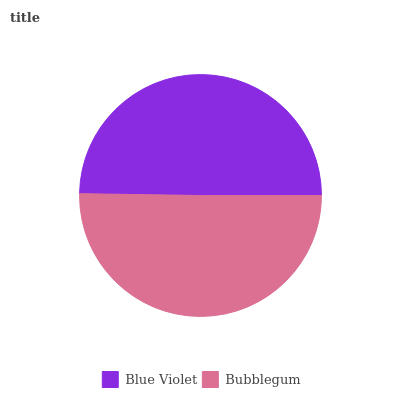Is Blue Violet the minimum?
Answer yes or no. Yes. Is Bubblegum the maximum?
Answer yes or no. Yes. Is Bubblegum the minimum?
Answer yes or no. No. Is Bubblegum greater than Blue Violet?
Answer yes or no. Yes. Is Blue Violet less than Bubblegum?
Answer yes or no. Yes. Is Blue Violet greater than Bubblegum?
Answer yes or no. No. Is Bubblegum less than Blue Violet?
Answer yes or no. No. Is Bubblegum the high median?
Answer yes or no. Yes. Is Blue Violet the low median?
Answer yes or no. Yes. Is Blue Violet the high median?
Answer yes or no. No. Is Bubblegum the low median?
Answer yes or no. No. 